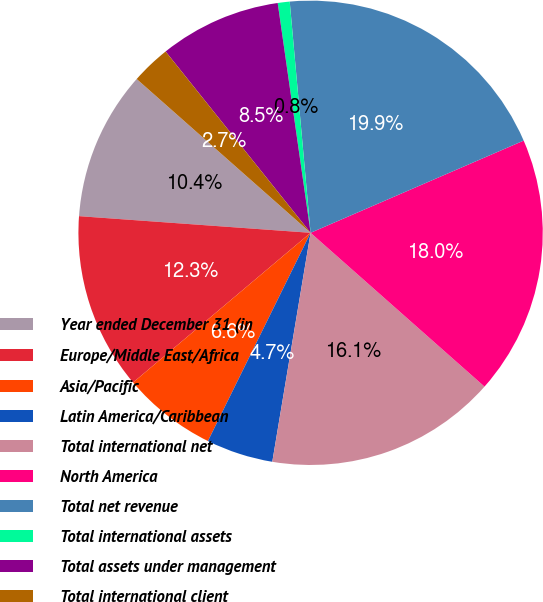<chart> <loc_0><loc_0><loc_500><loc_500><pie_chart><fcel>Year ended December 31 (in<fcel>Europe/Middle East/Africa<fcel>Asia/Pacific<fcel>Latin America/Caribbean<fcel>Total international net<fcel>North America<fcel>Total net revenue<fcel>Total international assets<fcel>Total assets under management<fcel>Total international client<nl><fcel>10.38%<fcel>12.29%<fcel>6.56%<fcel>4.65%<fcel>16.11%<fcel>18.02%<fcel>19.93%<fcel>0.83%<fcel>8.47%<fcel>2.74%<nl></chart> 